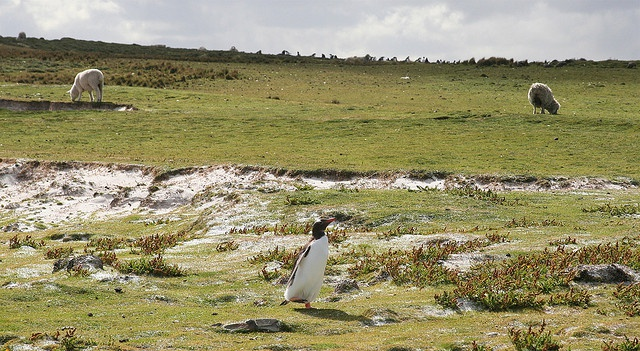Describe the objects in this image and their specific colors. I can see bird in lightgray, darkgray, black, and gray tones, sheep in lightgray, gray, darkgreen, and white tones, and sheep in lightgray, black, darkgreen, gray, and ivory tones in this image. 